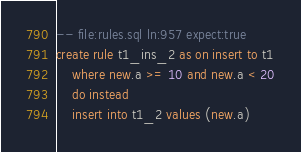Convert code to text. <code><loc_0><loc_0><loc_500><loc_500><_SQL_>-- file:rules.sql ln:957 expect:true
create rule t1_ins_2 as on insert to t1
	where new.a >= 10 and new.a < 20
	do instead
	insert into t1_2 values (new.a)
</code> 